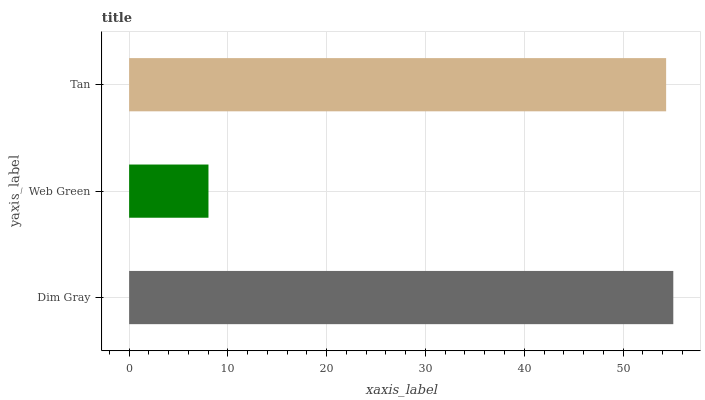Is Web Green the minimum?
Answer yes or no. Yes. Is Dim Gray the maximum?
Answer yes or no. Yes. Is Tan the minimum?
Answer yes or no. No. Is Tan the maximum?
Answer yes or no. No. Is Tan greater than Web Green?
Answer yes or no. Yes. Is Web Green less than Tan?
Answer yes or no. Yes. Is Web Green greater than Tan?
Answer yes or no. No. Is Tan less than Web Green?
Answer yes or no. No. Is Tan the high median?
Answer yes or no. Yes. Is Tan the low median?
Answer yes or no. Yes. Is Dim Gray the high median?
Answer yes or no. No. Is Dim Gray the low median?
Answer yes or no. No. 